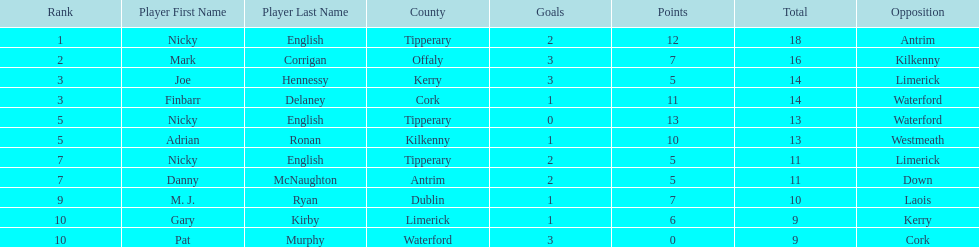Which of the following players were ranked in the bottom 5? Nicky English, Danny McNaughton, M. J. Ryan, Gary Kirby, Pat Murphy. Of these, whose tallies were not 2-5? M. J. Ryan, Gary Kirby, Pat Murphy. From the above three, which one scored more than 9 total points? M. J. Ryan. Could you parse the entire table? {'header': ['Rank', 'Player First Name', 'Player Last Name', 'County', 'Goals', 'Points', 'Total', 'Opposition'], 'rows': [['1', 'Nicky', 'English', 'Tipperary', '2', '12', '18', 'Antrim'], ['2', 'Mark', 'Corrigan', 'Offaly', '3', '7', '16', 'Kilkenny'], ['3', 'Joe', 'Hennessy', 'Kerry', '3', '5', '14', 'Limerick'], ['3', 'Finbarr', 'Delaney', 'Cork', '1', '11', '14', 'Waterford'], ['5', 'Nicky', 'English', 'Tipperary', '0', '13', '13', 'Waterford'], ['5', 'Adrian', 'Ronan', 'Kilkenny', '1', '10', '13', 'Westmeath'], ['7', 'Nicky', 'English', 'Tipperary', '2', '5', '11', 'Limerick'], ['7', 'Danny', 'McNaughton', 'Antrim', '2', '5', '11', 'Down'], ['9', 'M. J.', 'Ryan', 'Dublin', '1', '7', '10', 'Laois'], ['10', 'Gary', 'Kirby', 'Limerick', '1', '6', '9', 'Kerry'], ['10', 'Pat', 'Murphy', 'Waterford', '3', '0', '9', 'Cork']]} 